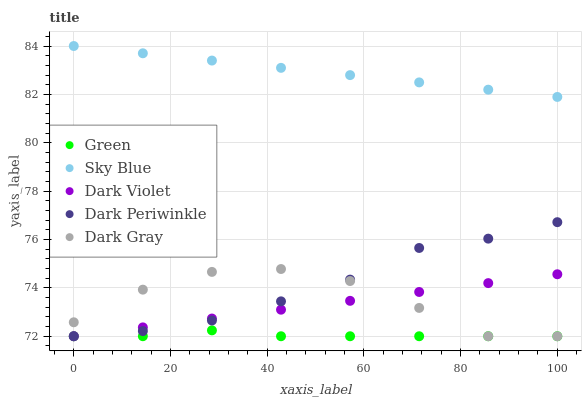Does Green have the minimum area under the curve?
Answer yes or no. Yes. Does Sky Blue have the maximum area under the curve?
Answer yes or no. Yes. Does Sky Blue have the minimum area under the curve?
Answer yes or no. No. Does Green have the maximum area under the curve?
Answer yes or no. No. Is Dark Violet the smoothest?
Answer yes or no. Yes. Is Dark Gray the roughest?
Answer yes or no. Yes. Is Sky Blue the smoothest?
Answer yes or no. No. Is Sky Blue the roughest?
Answer yes or no. No. Does Dark Gray have the lowest value?
Answer yes or no. Yes. Does Sky Blue have the lowest value?
Answer yes or no. No. Does Sky Blue have the highest value?
Answer yes or no. Yes. Does Green have the highest value?
Answer yes or no. No. Is Dark Gray less than Sky Blue?
Answer yes or no. Yes. Is Sky Blue greater than Dark Violet?
Answer yes or no. Yes. Does Dark Periwinkle intersect Green?
Answer yes or no. Yes. Is Dark Periwinkle less than Green?
Answer yes or no. No. Is Dark Periwinkle greater than Green?
Answer yes or no. No. Does Dark Gray intersect Sky Blue?
Answer yes or no. No. 